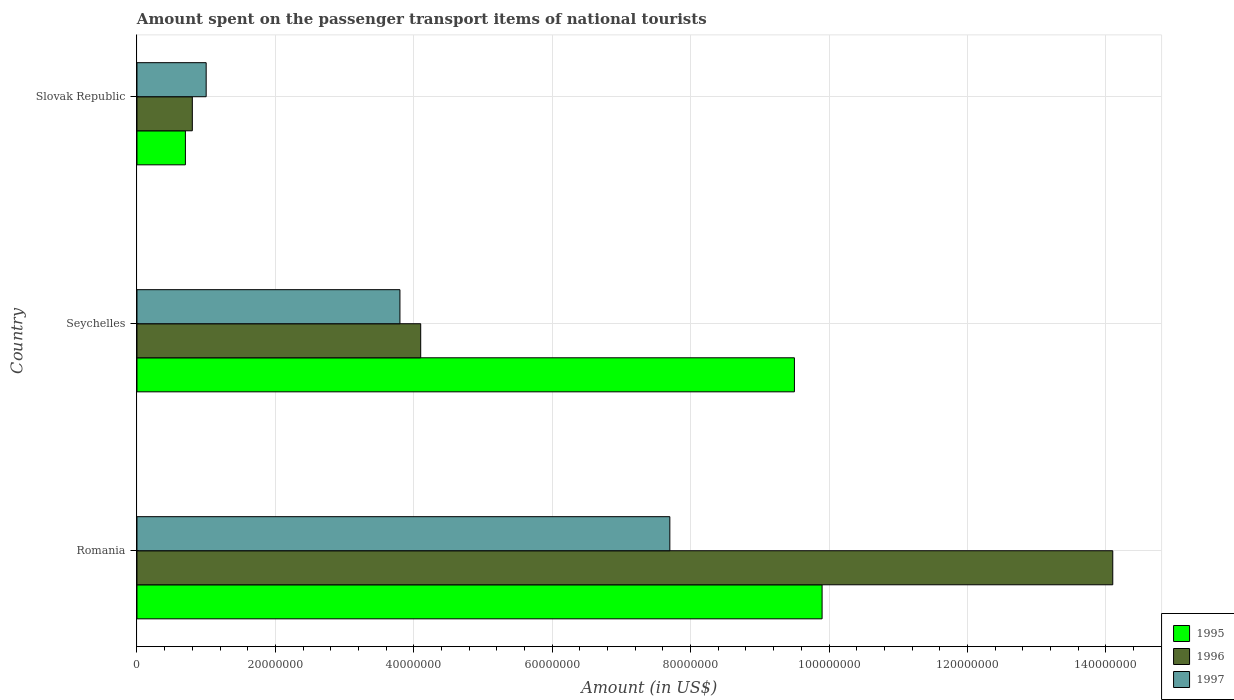How many groups of bars are there?
Your answer should be compact. 3. Are the number of bars per tick equal to the number of legend labels?
Make the answer very short. Yes. How many bars are there on the 1st tick from the top?
Your answer should be very brief. 3. How many bars are there on the 2nd tick from the bottom?
Ensure brevity in your answer.  3. What is the label of the 2nd group of bars from the top?
Make the answer very short. Seychelles. In how many cases, is the number of bars for a given country not equal to the number of legend labels?
Make the answer very short. 0. What is the amount spent on the passenger transport items of national tourists in 1996 in Romania?
Your answer should be very brief. 1.41e+08. Across all countries, what is the maximum amount spent on the passenger transport items of national tourists in 1996?
Provide a short and direct response. 1.41e+08. In which country was the amount spent on the passenger transport items of national tourists in 1997 maximum?
Your response must be concise. Romania. In which country was the amount spent on the passenger transport items of national tourists in 1996 minimum?
Your answer should be very brief. Slovak Republic. What is the total amount spent on the passenger transport items of national tourists in 1996 in the graph?
Provide a succinct answer. 1.90e+08. What is the difference between the amount spent on the passenger transport items of national tourists in 1996 in Romania and that in Seychelles?
Your answer should be compact. 1.00e+08. What is the difference between the amount spent on the passenger transport items of national tourists in 1995 in Slovak Republic and the amount spent on the passenger transport items of national tourists in 1996 in Seychelles?
Your answer should be very brief. -3.40e+07. What is the average amount spent on the passenger transport items of national tourists in 1995 per country?
Make the answer very short. 6.70e+07. What is the ratio of the amount spent on the passenger transport items of national tourists in 1997 in Romania to that in Seychelles?
Ensure brevity in your answer.  2.03. What is the difference between the highest and the lowest amount spent on the passenger transport items of national tourists in 1995?
Your answer should be compact. 9.20e+07. In how many countries, is the amount spent on the passenger transport items of national tourists in 1996 greater than the average amount spent on the passenger transport items of national tourists in 1996 taken over all countries?
Your response must be concise. 1. What does the 3rd bar from the top in Slovak Republic represents?
Keep it short and to the point. 1995. Is it the case that in every country, the sum of the amount spent on the passenger transport items of national tourists in 1996 and amount spent on the passenger transport items of national tourists in 1997 is greater than the amount spent on the passenger transport items of national tourists in 1995?
Your answer should be very brief. No. What is the difference between two consecutive major ticks on the X-axis?
Provide a short and direct response. 2.00e+07. Does the graph contain any zero values?
Offer a terse response. No. Does the graph contain grids?
Provide a succinct answer. Yes. Where does the legend appear in the graph?
Offer a terse response. Bottom right. What is the title of the graph?
Your answer should be very brief. Amount spent on the passenger transport items of national tourists. Does "1980" appear as one of the legend labels in the graph?
Provide a succinct answer. No. What is the label or title of the Y-axis?
Make the answer very short. Country. What is the Amount (in US$) of 1995 in Romania?
Offer a very short reply. 9.90e+07. What is the Amount (in US$) of 1996 in Romania?
Make the answer very short. 1.41e+08. What is the Amount (in US$) in 1997 in Romania?
Offer a terse response. 7.70e+07. What is the Amount (in US$) of 1995 in Seychelles?
Give a very brief answer. 9.50e+07. What is the Amount (in US$) of 1996 in Seychelles?
Ensure brevity in your answer.  4.10e+07. What is the Amount (in US$) of 1997 in Seychelles?
Ensure brevity in your answer.  3.80e+07. Across all countries, what is the maximum Amount (in US$) in 1995?
Your answer should be very brief. 9.90e+07. Across all countries, what is the maximum Amount (in US$) in 1996?
Your answer should be very brief. 1.41e+08. Across all countries, what is the maximum Amount (in US$) of 1997?
Offer a very short reply. 7.70e+07. Across all countries, what is the minimum Amount (in US$) of 1995?
Your answer should be compact. 7.00e+06. Across all countries, what is the minimum Amount (in US$) of 1996?
Your response must be concise. 8.00e+06. What is the total Amount (in US$) of 1995 in the graph?
Your answer should be compact. 2.01e+08. What is the total Amount (in US$) of 1996 in the graph?
Your response must be concise. 1.90e+08. What is the total Amount (in US$) of 1997 in the graph?
Offer a terse response. 1.25e+08. What is the difference between the Amount (in US$) in 1996 in Romania and that in Seychelles?
Your answer should be compact. 1.00e+08. What is the difference between the Amount (in US$) in 1997 in Romania and that in Seychelles?
Your answer should be compact. 3.90e+07. What is the difference between the Amount (in US$) of 1995 in Romania and that in Slovak Republic?
Provide a succinct answer. 9.20e+07. What is the difference between the Amount (in US$) of 1996 in Romania and that in Slovak Republic?
Your answer should be very brief. 1.33e+08. What is the difference between the Amount (in US$) in 1997 in Romania and that in Slovak Republic?
Provide a short and direct response. 6.70e+07. What is the difference between the Amount (in US$) of 1995 in Seychelles and that in Slovak Republic?
Offer a very short reply. 8.80e+07. What is the difference between the Amount (in US$) in 1996 in Seychelles and that in Slovak Republic?
Ensure brevity in your answer.  3.30e+07. What is the difference between the Amount (in US$) in 1997 in Seychelles and that in Slovak Republic?
Ensure brevity in your answer.  2.80e+07. What is the difference between the Amount (in US$) in 1995 in Romania and the Amount (in US$) in 1996 in Seychelles?
Ensure brevity in your answer.  5.80e+07. What is the difference between the Amount (in US$) of 1995 in Romania and the Amount (in US$) of 1997 in Seychelles?
Provide a succinct answer. 6.10e+07. What is the difference between the Amount (in US$) of 1996 in Romania and the Amount (in US$) of 1997 in Seychelles?
Keep it short and to the point. 1.03e+08. What is the difference between the Amount (in US$) in 1995 in Romania and the Amount (in US$) in 1996 in Slovak Republic?
Your answer should be compact. 9.10e+07. What is the difference between the Amount (in US$) in 1995 in Romania and the Amount (in US$) in 1997 in Slovak Republic?
Give a very brief answer. 8.90e+07. What is the difference between the Amount (in US$) of 1996 in Romania and the Amount (in US$) of 1997 in Slovak Republic?
Your response must be concise. 1.31e+08. What is the difference between the Amount (in US$) of 1995 in Seychelles and the Amount (in US$) of 1996 in Slovak Republic?
Your answer should be very brief. 8.70e+07. What is the difference between the Amount (in US$) in 1995 in Seychelles and the Amount (in US$) in 1997 in Slovak Republic?
Your answer should be compact. 8.50e+07. What is the difference between the Amount (in US$) in 1996 in Seychelles and the Amount (in US$) in 1997 in Slovak Republic?
Make the answer very short. 3.10e+07. What is the average Amount (in US$) of 1995 per country?
Your answer should be compact. 6.70e+07. What is the average Amount (in US$) in 1996 per country?
Give a very brief answer. 6.33e+07. What is the average Amount (in US$) of 1997 per country?
Provide a succinct answer. 4.17e+07. What is the difference between the Amount (in US$) in 1995 and Amount (in US$) in 1996 in Romania?
Offer a very short reply. -4.20e+07. What is the difference between the Amount (in US$) in 1995 and Amount (in US$) in 1997 in Romania?
Give a very brief answer. 2.20e+07. What is the difference between the Amount (in US$) of 1996 and Amount (in US$) of 1997 in Romania?
Keep it short and to the point. 6.40e+07. What is the difference between the Amount (in US$) in 1995 and Amount (in US$) in 1996 in Seychelles?
Offer a very short reply. 5.40e+07. What is the difference between the Amount (in US$) in 1995 and Amount (in US$) in 1997 in Seychelles?
Your answer should be very brief. 5.70e+07. What is the difference between the Amount (in US$) of 1996 and Amount (in US$) of 1997 in Seychelles?
Offer a terse response. 3.00e+06. What is the difference between the Amount (in US$) of 1995 and Amount (in US$) of 1997 in Slovak Republic?
Offer a terse response. -3.00e+06. What is the difference between the Amount (in US$) in 1996 and Amount (in US$) in 1997 in Slovak Republic?
Make the answer very short. -2.00e+06. What is the ratio of the Amount (in US$) of 1995 in Romania to that in Seychelles?
Your answer should be very brief. 1.04. What is the ratio of the Amount (in US$) of 1996 in Romania to that in Seychelles?
Your answer should be very brief. 3.44. What is the ratio of the Amount (in US$) in 1997 in Romania to that in Seychelles?
Keep it short and to the point. 2.03. What is the ratio of the Amount (in US$) in 1995 in Romania to that in Slovak Republic?
Offer a terse response. 14.14. What is the ratio of the Amount (in US$) of 1996 in Romania to that in Slovak Republic?
Ensure brevity in your answer.  17.62. What is the ratio of the Amount (in US$) in 1997 in Romania to that in Slovak Republic?
Keep it short and to the point. 7.7. What is the ratio of the Amount (in US$) of 1995 in Seychelles to that in Slovak Republic?
Your answer should be compact. 13.57. What is the ratio of the Amount (in US$) of 1996 in Seychelles to that in Slovak Republic?
Provide a short and direct response. 5.12. What is the ratio of the Amount (in US$) of 1997 in Seychelles to that in Slovak Republic?
Make the answer very short. 3.8. What is the difference between the highest and the second highest Amount (in US$) of 1995?
Your response must be concise. 4.00e+06. What is the difference between the highest and the second highest Amount (in US$) in 1997?
Give a very brief answer. 3.90e+07. What is the difference between the highest and the lowest Amount (in US$) of 1995?
Keep it short and to the point. 9.20e+07. What is the difference between the highest and the lowest Amount (in US$) of 1996?
Give a very brief answer. 1.33e+08. What is the difference between the highest and the lowest Amount (in US$) in 1997?
Ensure brevity in your answer.  6.70e+07. 